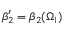<formula> <loc_0><loc_0><loc_500><loc_500>\beta _ { 2 } ^ { \prime } = \beta _ { 2 } ( \Omega _ { 1 } )</formula> 